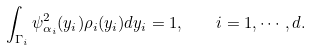Convert formula to latex. <formula><loc_0><loc_0><loc_500><loc_500>\int _ { \Gamma _ { i } } \psi _ { \alpha _ { i } } ^ { 2 } ( y _ { i } ) \rho _ { i } ( y _ { i } ) d y _ { i } = 1 , \quad i = 1 , \cdots , d .</formula> 